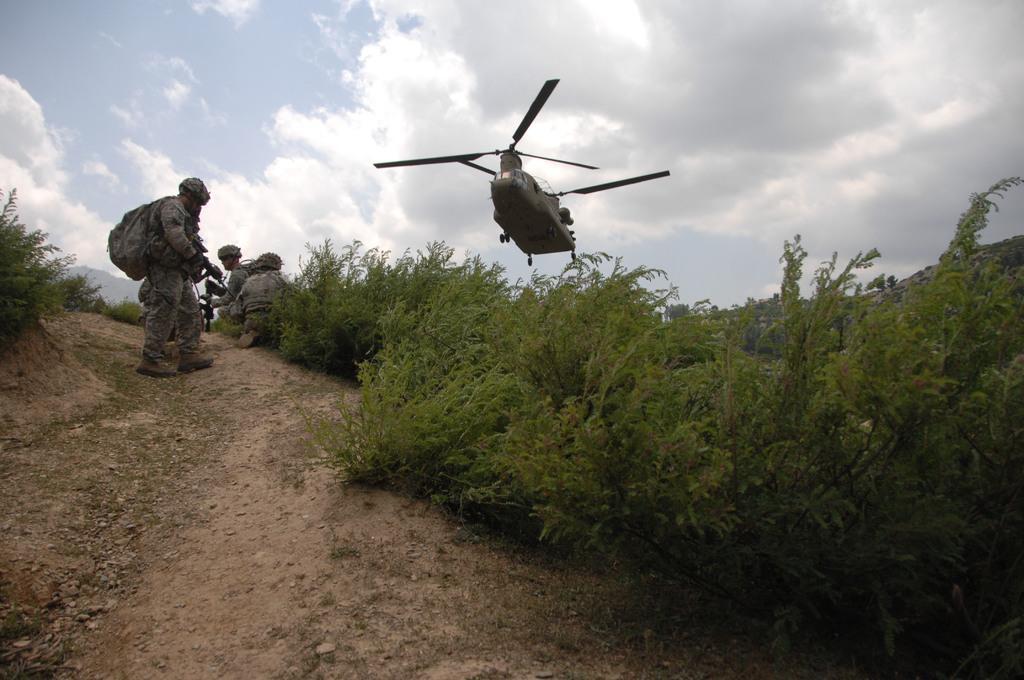Can you describe this image briefly? In this picture we can see some army people, plane, around we can see some trees. 